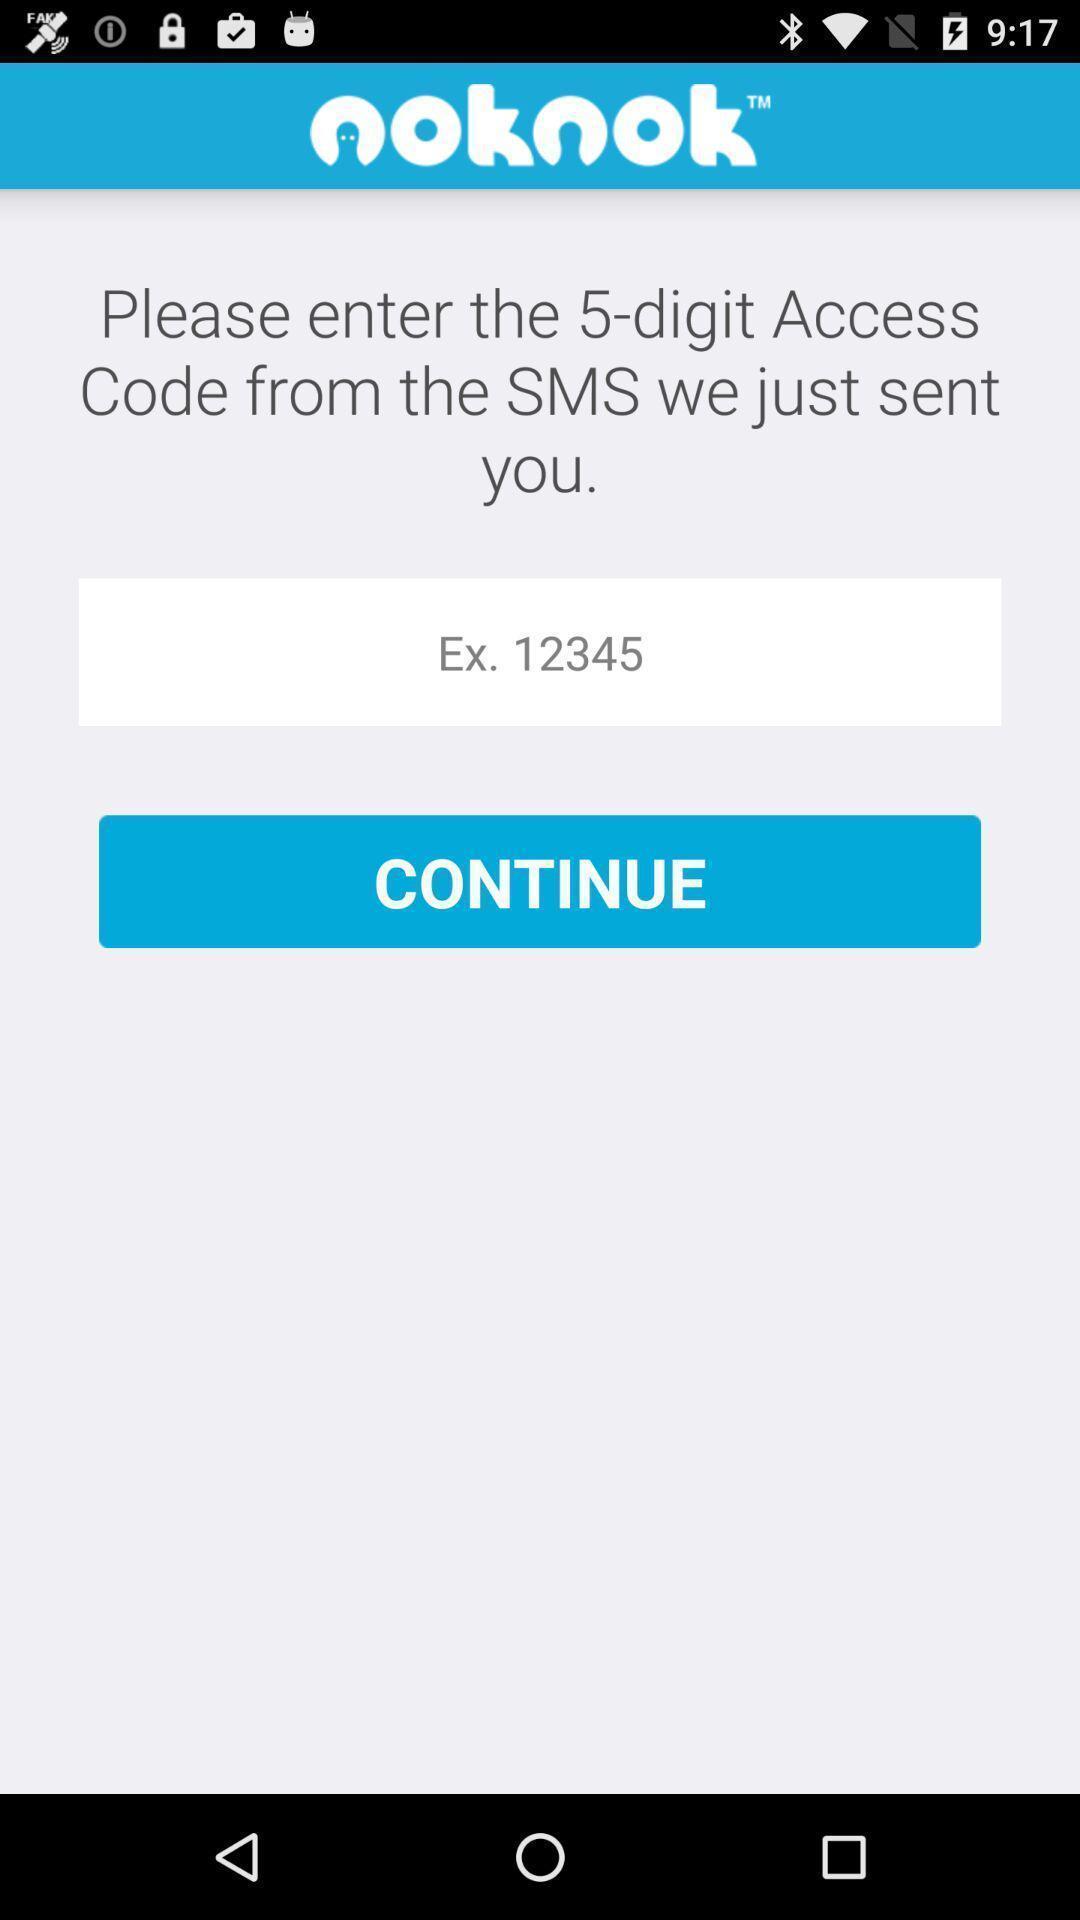Tell me about the visual elements in this screen capture. Verification page to confirm number. 